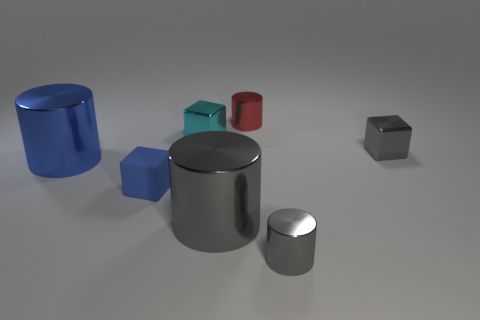Is there any other thing that has the same material as the blue block?
Keep it short and to the point. No. How many other objects are the same material as the cyan block?
Offer a terse response. 5. What is the material of the gray cylinder that is the same size as the blue cylinder?
Keep it short and to the point. Metal. Is the color of the cube that is behind the gray block the same as the big shiny object right of the rubber thing?
Offer a very short reply. No. Are there any other small red things that have the same shape as the red thing?
Ensure brevity in your answer.  No. There is a red metal object that is the same size as the cyan metal object; what shape is it?
Your response must be concise. Cylinder. What number of other matte cubes are the same color as the matte cube?
Offer a terse response. 0. What is the size of the shiny cube to the left of the small red metal object?
Offer a terse response. Small. What number of other blue matte blocks are the same size as the blue cube?
Keep it short and to the point. 0. What color is the other small cylinder that is made of the same material as the red cylinder?
Provide a succinct answer. Gray. 